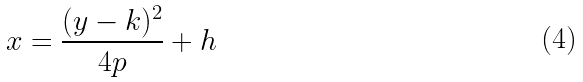<formula> <loc_0><loc_0><loc_500><loc_500>x = \frac { ( y - k ) ^ { 2 } } { 4 p } + h</formula> 